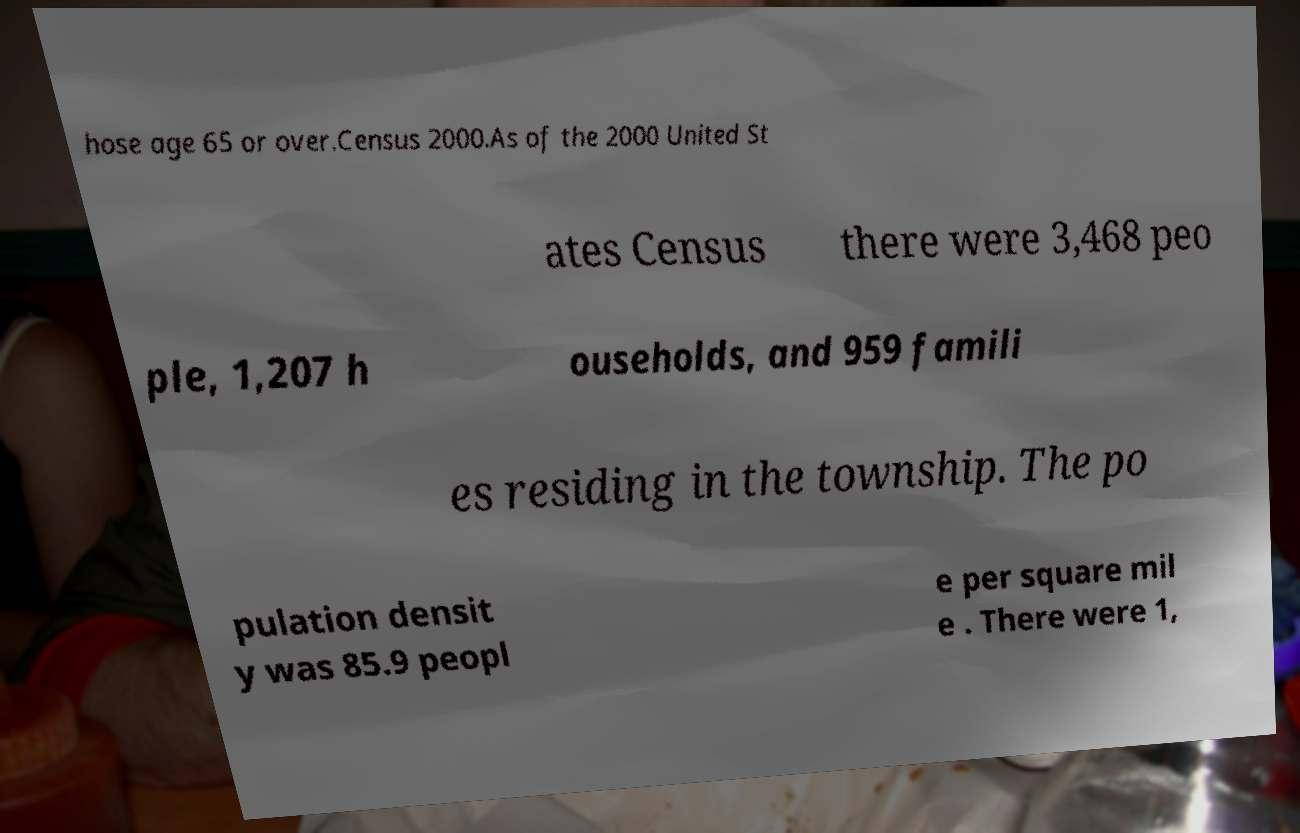Could you extract and type out the text from this image? hose age 65 or over.Census 2000.As of the 2000 United St ates Census there were 3,468 peo ple, 1,207 h ouseholds, and 959 famili es residing in the township. The po pulation densit y was 85.9 peopl e per square mil e . There were 1, 